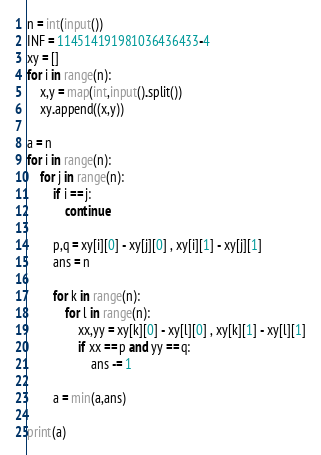<code> <loc_0><loc_0><loc_500><loc_500><_Python_>n = int(input())
INF = 114514191981036436433-4
xy = []
for i in range(n):
    x,y = map(int,input().split())
    xy.append((x,y))
    
a = n
for i in range(n):
    for j in range(n):
        if i == j:
            continue
            
        p,q = xy[i][0] - xy[j][0] , xy[i][1] - xy[j][1]
        ans = n
        
        for k in range(n):
            for l in range(n):
                xx,yy = xy[k][0] - xy[l][0] , xy[k][1] - xy[l][1]
                if xx == p and yy == q:
                    ans -= 1
                    
        a = min(a,ans)
        
print(a)</code> 